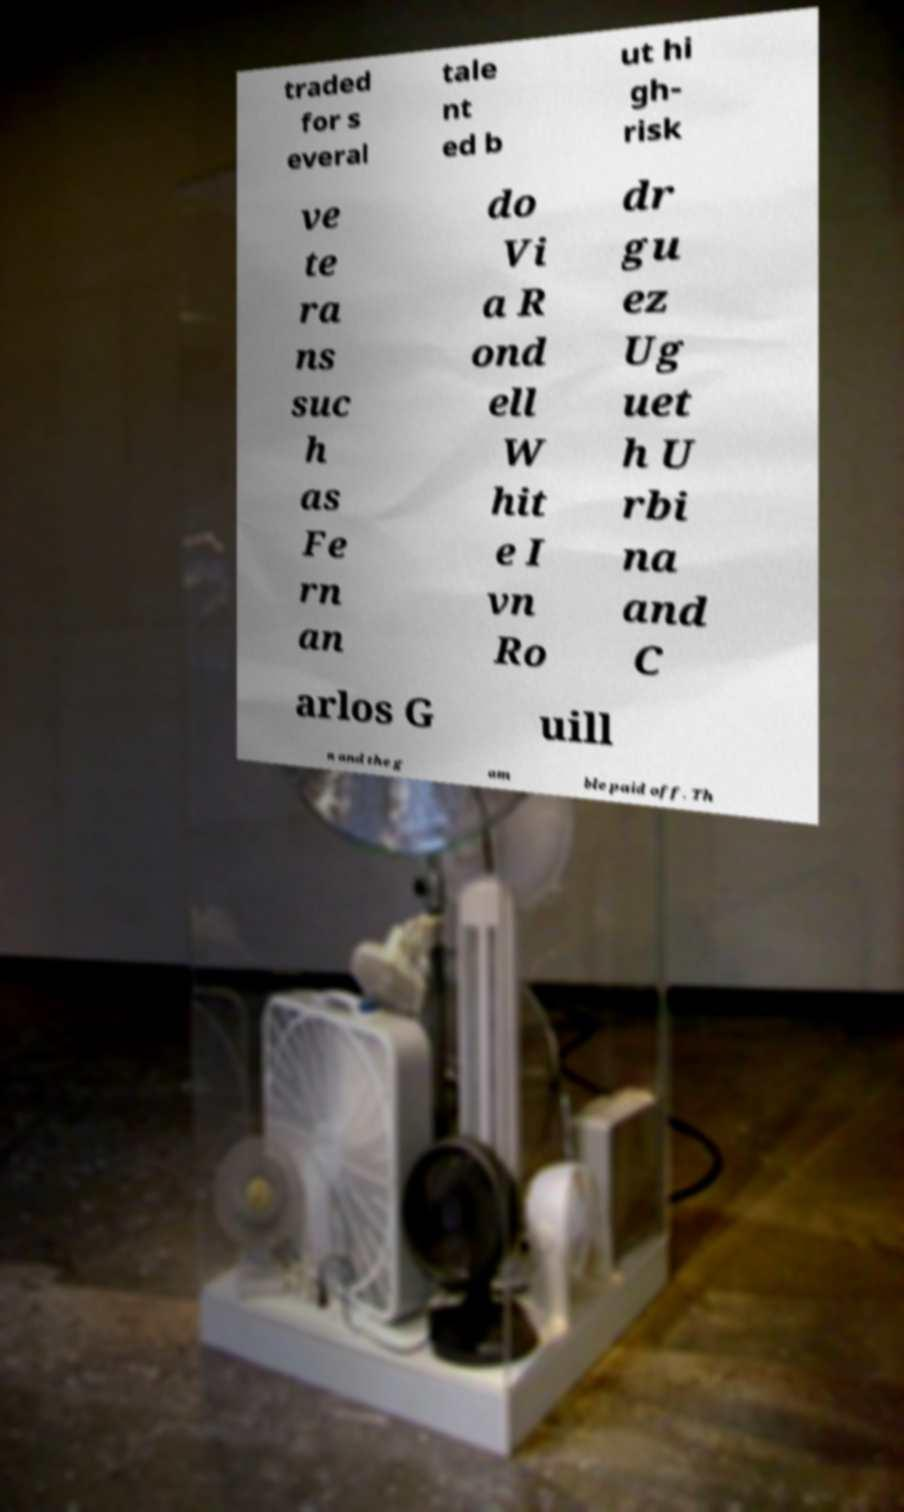Can you accurately transcribe the text from the provided image for me? traded for s everal tale nt ed b ut hi gh- risk ve te ra ns suc h as Fe rn an do Vi a R ond ell W hit e I vn Ro dr gu ez Ug uet h U rbi na and C arlos G uill n and the g am ble paid off. Th 